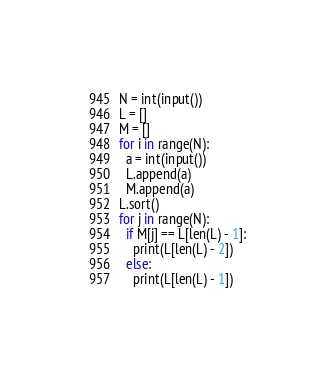Convert code to text. <code><loc_0><loc_0><loc_500><loc_500><_Python_>N = int(input())
L = []
M = []
for i in range(N):
  a = int(input())
  L.append(a)
  M.append(a)
L.sort()
for j in range(N):
  if M[j] == L[len(L) - 1]:
    print(L[len(L) - 2])
  else:
    print(L[len(L) - 1])</code> 